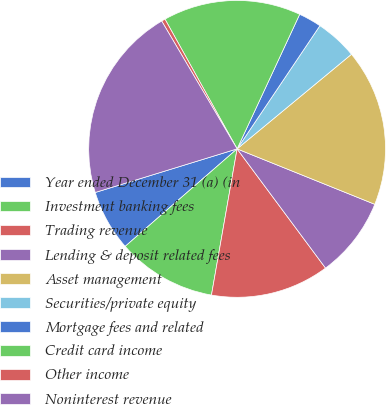Convert chart to OTSL. <chart><loc_0><loc_0><loc_500><loc_500><pie_chart><fcel>Year ended December 31 (a) (in<fcel>Investment banking fees<fcel>Trading revenue<fcel>Lending & deposit related fees<fcel>Asset management<fcel>Securities/private equity<fcel>Mortgage fees and related<fcel>Credit card income<fcel>Other income<fcel>Noninterest revenue<nl><fcel>6.66%<fcel>10.83%<fcel>12.92%<fcel>8.75%<fcel>17.09%<fcel>4.58%<fcel>2.49%<fcel>15.0%<fcel>0.41%<fcel>21.26%<nl></chart> 